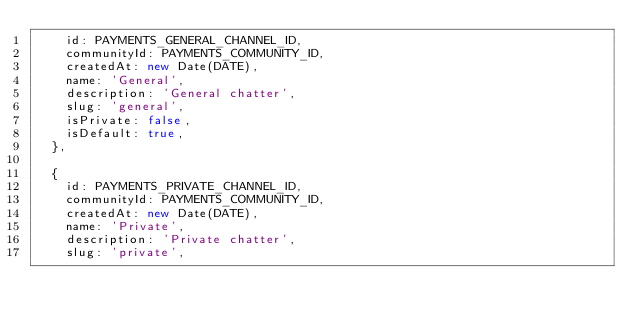<code> <loc_0><loc_0><loc_500><loc_500><_JavaScript_>    id: PAYMENTS_GENERAL_CHANNEL_ID,
    communityId: PAYMENTS_COMMUNITY_ID,
    createdAt: new Date(DATE),
    name: 'General',
    description: 'General chatter',
    slug: 'general',
    isPrivate: false,
    isDefault: true,
  },

  {
    id: PAYMENTS_PRIVATE_CHANNEL_ID,
    communityId: PAYMENTS_COMMUNITY_ID,
    createdAt: new Date(DATE),
    name: 'Private',
    description: 'Private chatter',
    slug: 'private',</code> 